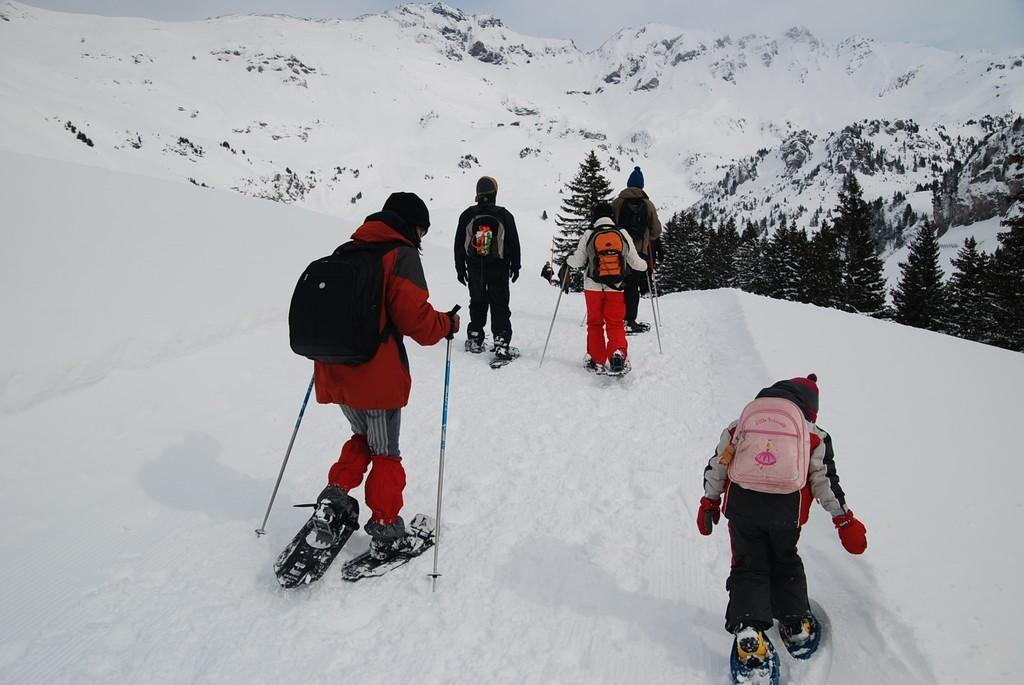Who or what can be seen in the image? There are people in the image. What are the people doing in the image? The people are skating. On what surface are the people skating? The skating is taking place on snow. What can be seen on the right side of the image? There are trees on the right side of the image. What type of scissors can be seen being used by the people in the image? There are no scissors present in the image; the people are skating on snow. What is the name of the person skating in the image? The provided facts do not include any names of the people in the image. 